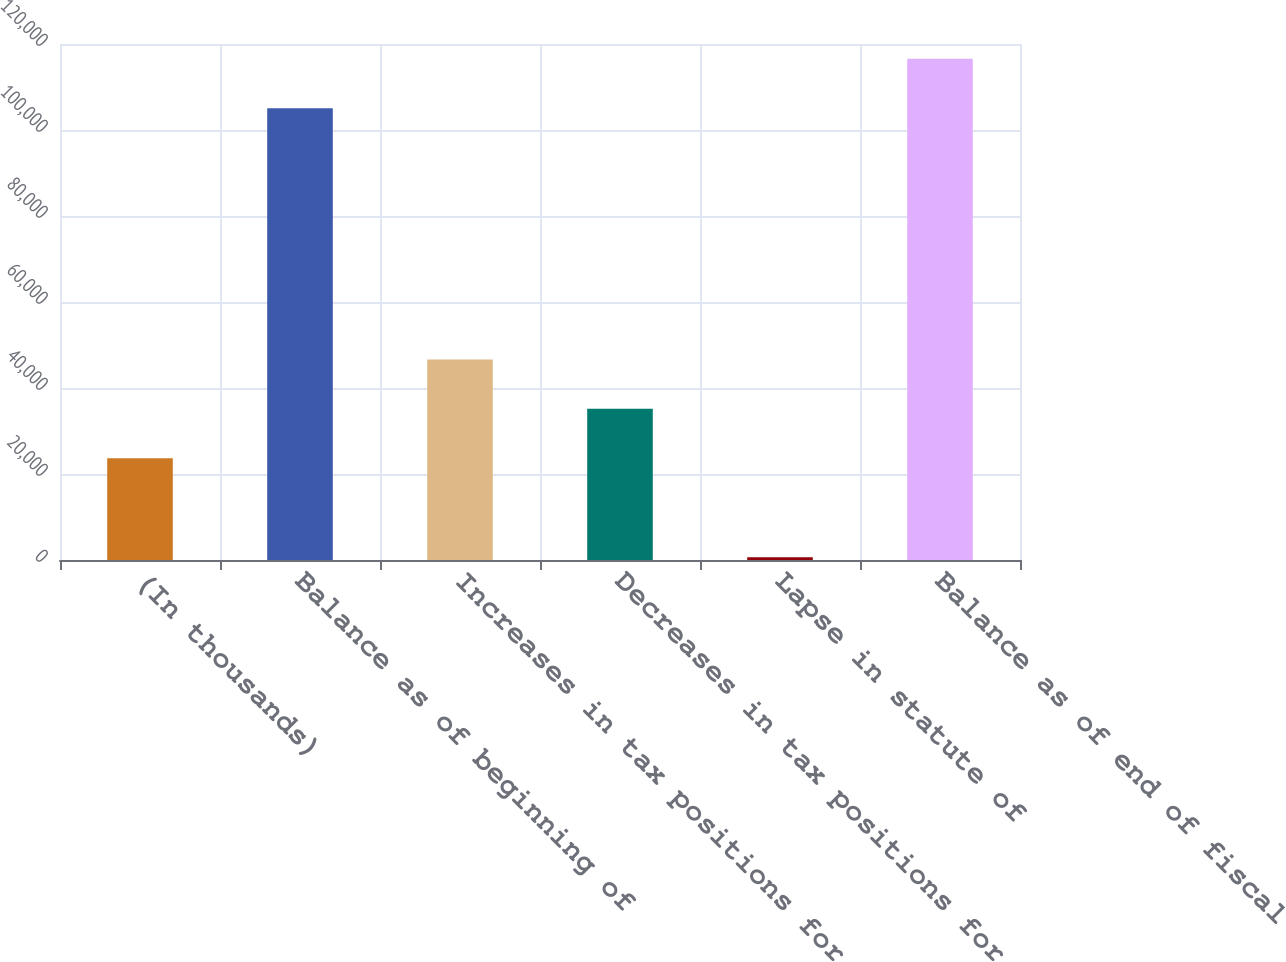Convert chart. <chart><loc_0><loc_0><loc_500><loc_500><bar_chart><fcel>(In thousands)<fcel>Balance as of beginning of<fcel>Increases in tax positions for<fcel>Decreases in tax positions for<fcel>Lapse in statute of<fcel>Balance as of end of fiscal<nl><fcel>23653<fcel>105079<fcel>46649<fcel>35151<fcel>657<fcel>116577<nl></chart> 